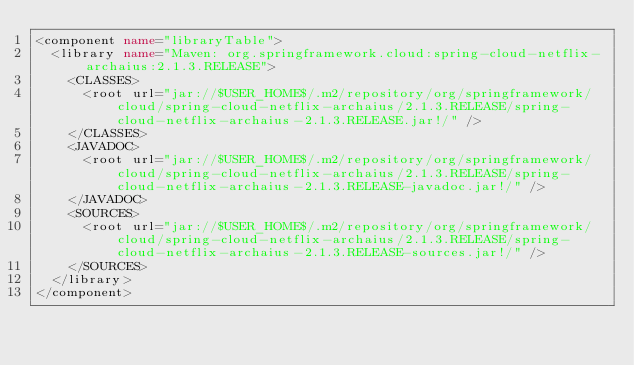<code> <loc_0><loc_0><loc_500><loc_500><_XML_><component name="libraryTable">
  <library name="Maven: org.springframework.cloud:spring-cloud-netflix-archaius:2.1.3.RELEASE">
    <CLASSES>
      <root url="jar://$USER_HOME$/.m2/repository/org/springframework/cloud/spring-cloud-netflix-archaius/2.1.3.RELEASE/spring-cloud-netflix-archaius-2.1.3.RELEASE.jar!/" />
    </CLASSES>
    <JAVADOC>
      <root url="jar://$USER_HOME$/.m2/repository/org/springframework/cloud/spring-cloud-netflix-archaius/2.1.3.RELEASE/spring-cloud-netflix-archaius-2.1.3.RELEASE-javadoc.jar!/" />
    </JAVADOC>
    <SOURCES>
      <root url="jar://$USER_HOME$/.m2/repository/org/springframework/cloud/spring-cloud-netflix-archaius/2.1.3.RELEASE/spring-cloud-netflix-archaius-2.1.3.RELEASE-sources.jar!/" />
    </SOURCES>
  </library>
</component></code> 